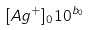<formula> <loc_0><loc_0><loc_500><loc_500>[ A g ^ { + } ] _ { 0 } 1 0 ^ { b _ { 0 } }</formula> 